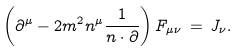Convert formula to latex. <formula><loc_0><loc_0><loc_500><loc_500>\left ( \partial ^ { \mu } - 2 m ^ { 2 } n ^ { \mu } \frac { 1 } { n \cdot \partial } \right ) F _ { \mu \nu } \, = \, J _ { \nu } .</formula> 